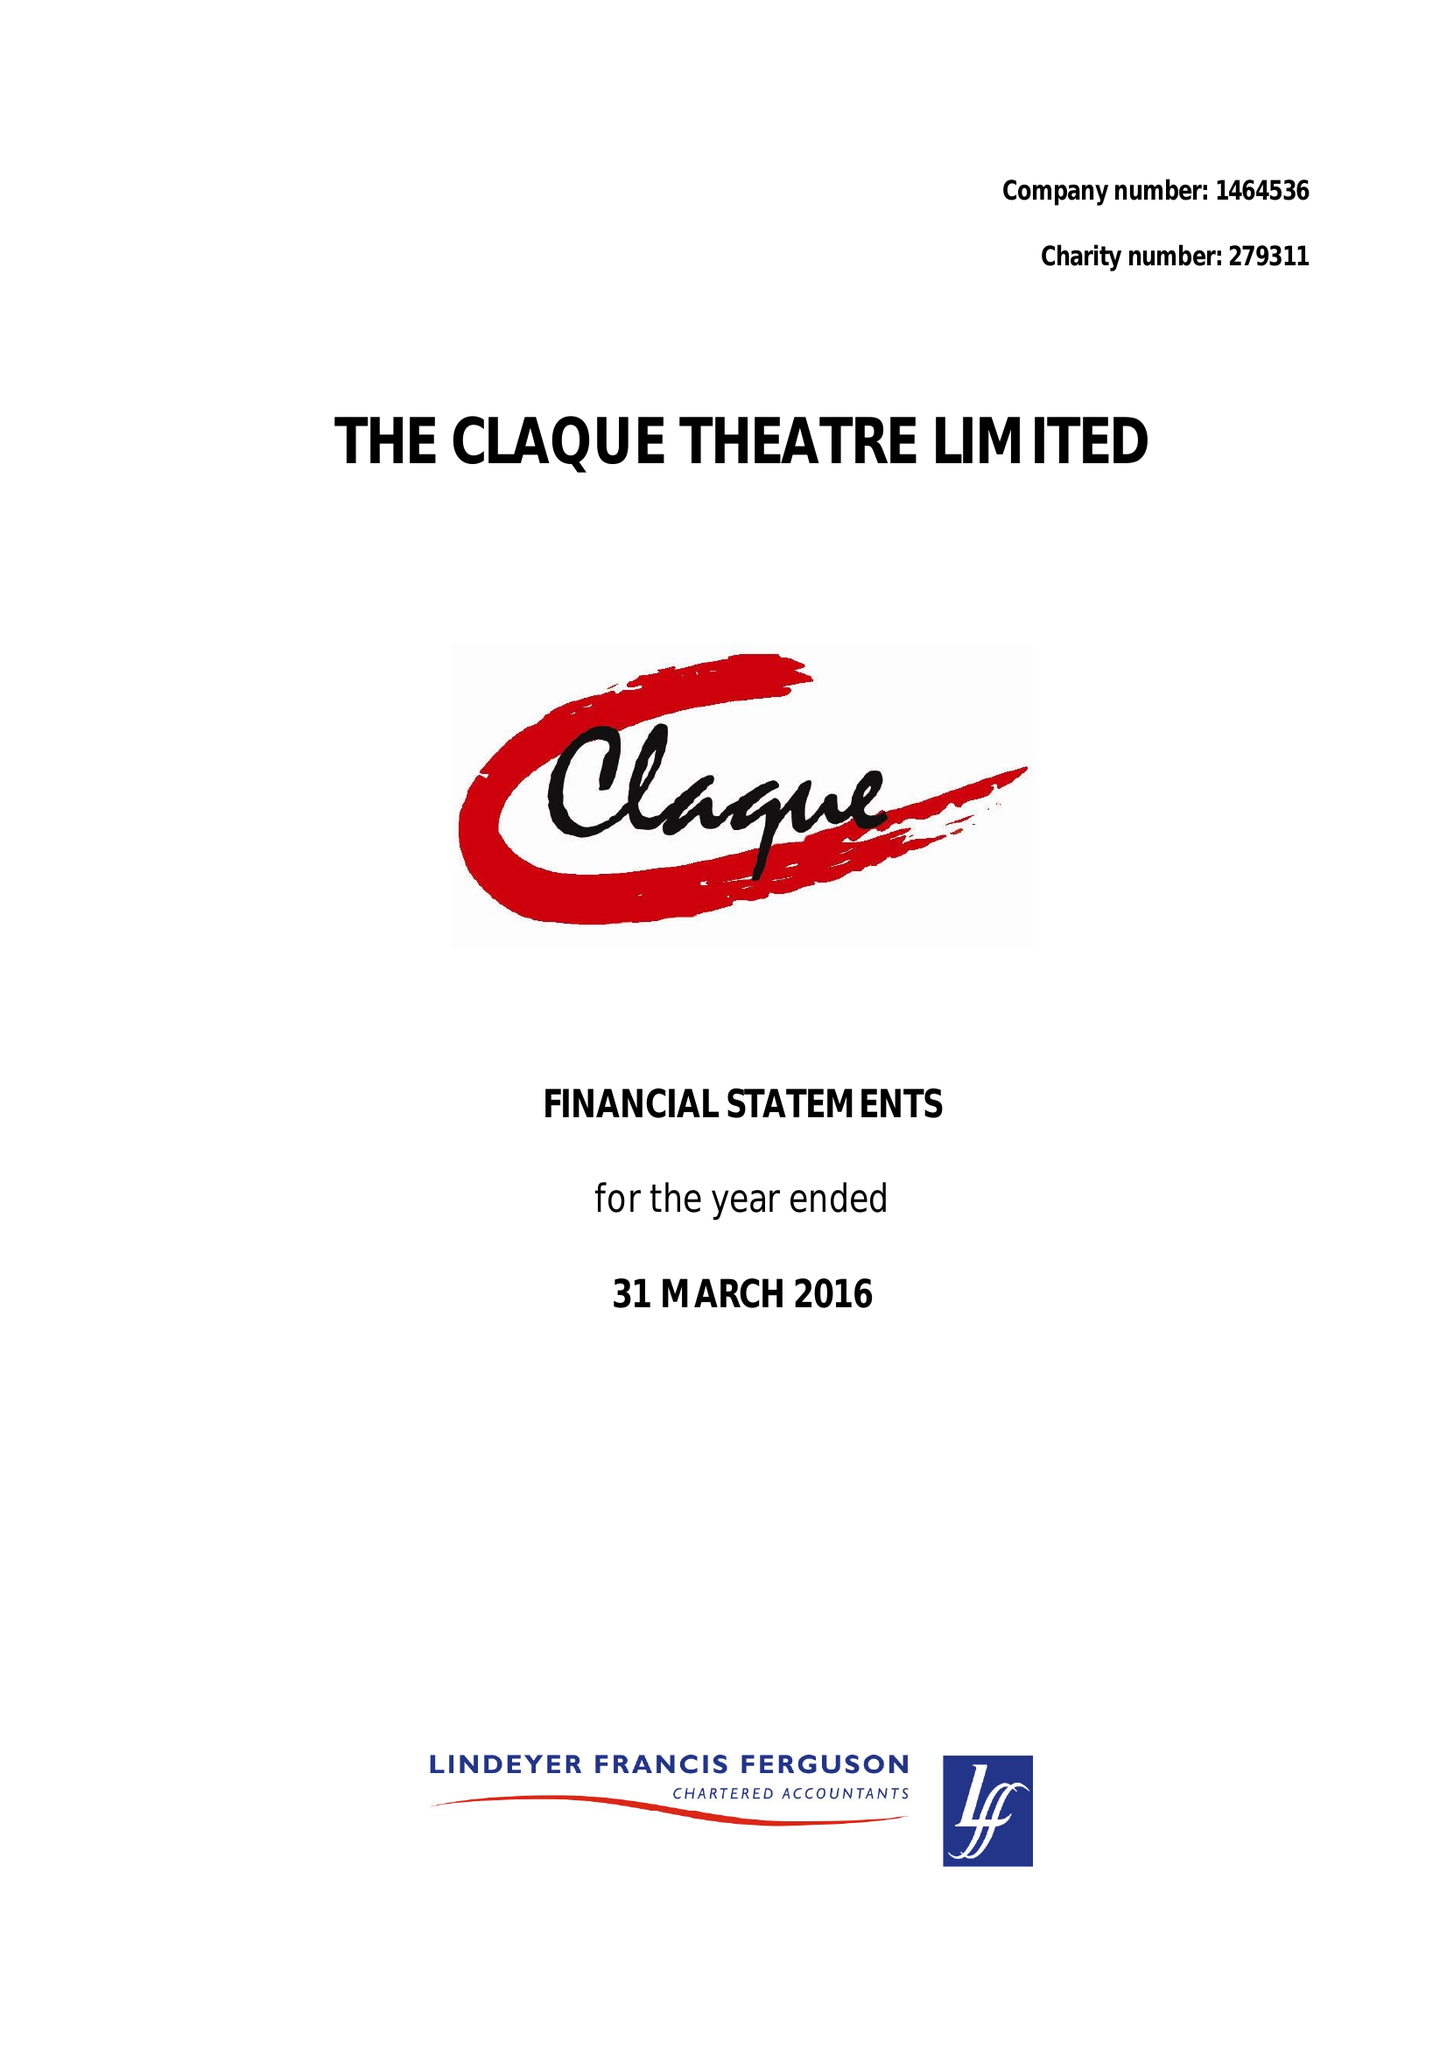What is the value for the spending_annually_in_british_pounds?
Answer the question using a single word or phrase. 13492.00 